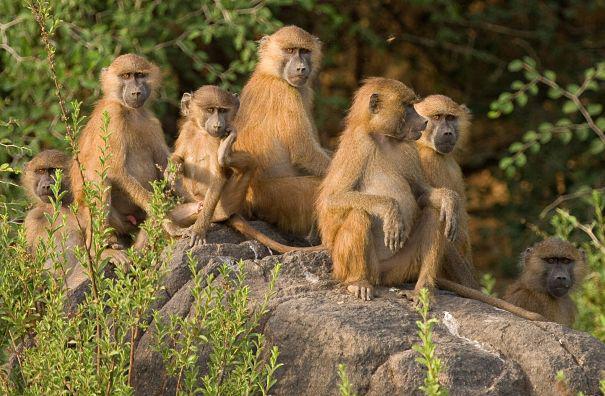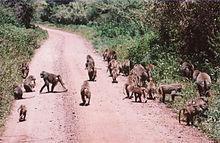The first image is the image on the left, the second image is the image on the right. Assess this claim about the two images: "The right image shows a large group of animals on a road.". Correct or not? Answer yes or no. Yes. The first image is the image on the left, the second image is the image on the right. Considering the images on both sides, is "One image has no more than 7 baboons." valid? Answer yes or no. Yes. 